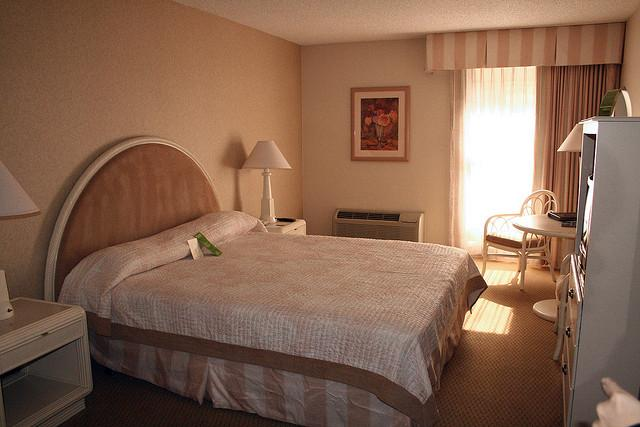What venue is shown here? hotel 